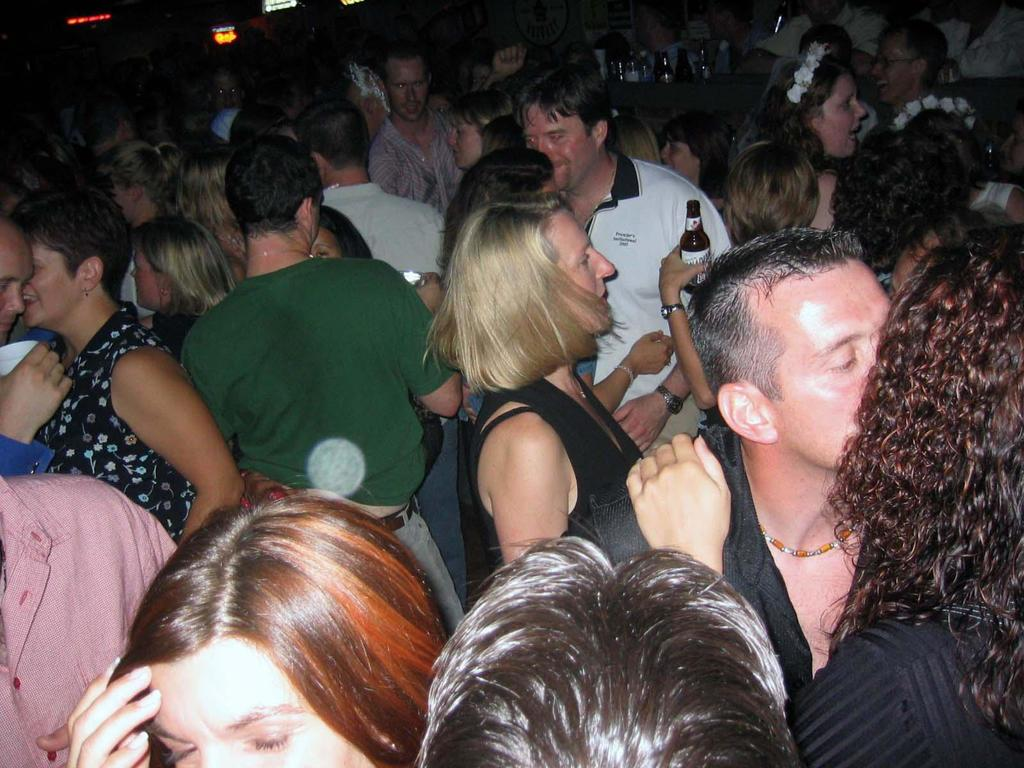What is happening in the image involving the groups of people? There are groups of people standing in the image. Can you describe the actions of any individuals in the image? A person is holding a bottle in the image. What can be seen in the background of the image? There are bottles on an object in the background of the image, and the background is dark. What type of brass instrument is being played by the person in the image? There is no brass instrument present in the image; only people standing and a person holding a bottle are visible. 